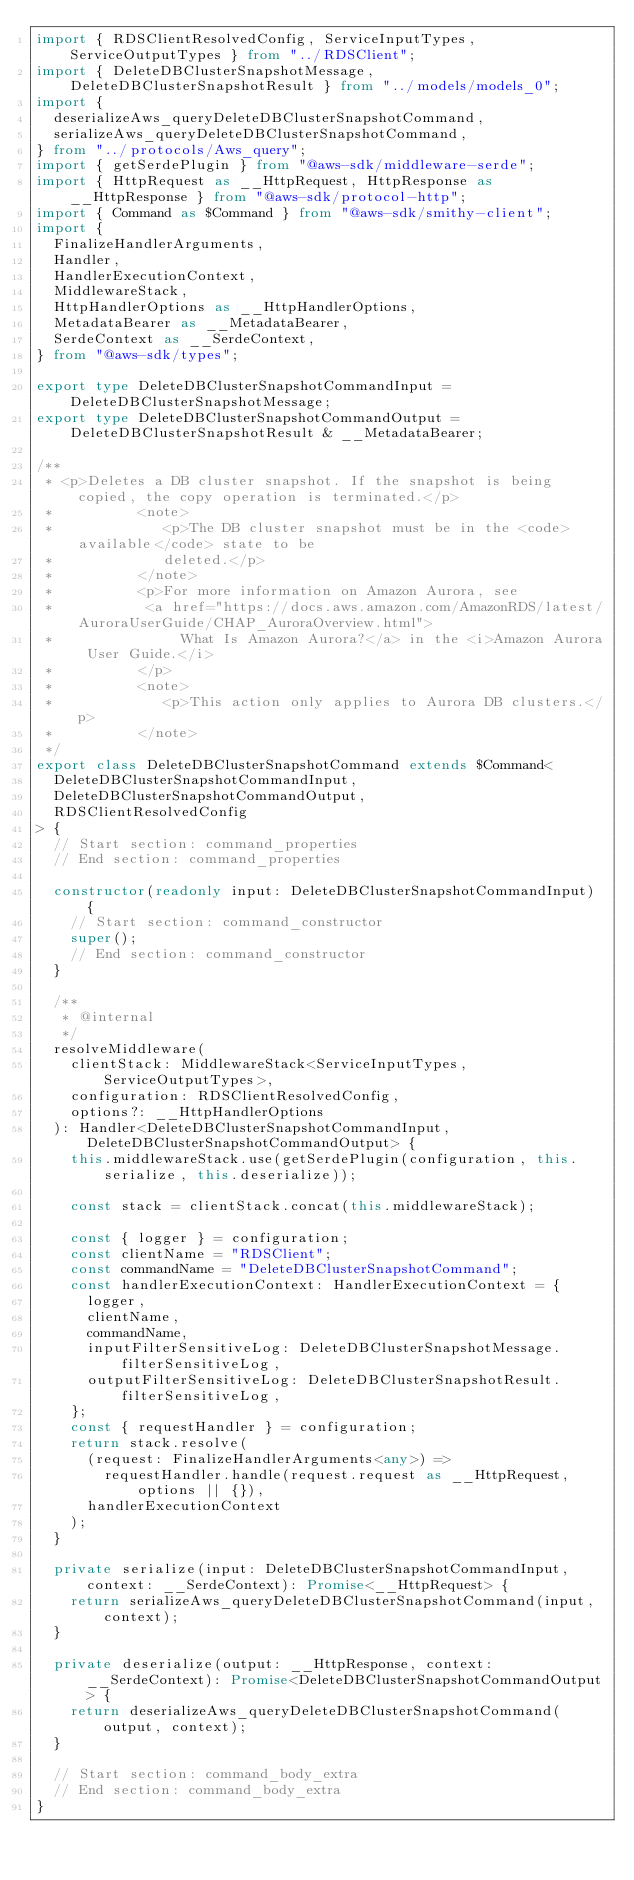Convert code to text. <code><loc_0><loc_0><loc_500><loc_500><_TypeScript_>import { RDSClientResolvedConfig, ServiceInputTypes, ServiceOutputTypes } from "../RDSClient";
import { DeleteDBClusterSnapshotMessage, DeleteDBClusterSnapshotResult } from "../models/models_0";
import {
  deserializeAws_queryDeleteDBClusterSnapshotCommand,
  serializeAws_queryDeleteDBClusterSnapshotCommand,
} from "../protocols/Aws_query";
import { getSerdePlugin } from "@aws-sdk/middleware-serde";
import { HttpRequest as __HttpRequest, HttpResponse as __HttpResponse } from "@aws-sdk/protocol-http";
import { Command as $Command } from "@aws-sdk/smithy-client";
import {
  FinalizeHandlerArguments,
  Handler,
  HandlerExecutionContext,
  MiddlewareStack,
  HttpHandlerOptions as __HttpHandlerOptions,
  MetadataBearer as __MetadataBearer,
  SerdeContext as __SerdeContext,
} from "@aws-sdk/types";

export type DeleteDBClusterSnapshotCommandInput = DeleteDBClusterSnapshotMessage;
export type DeleteDBClusterSnapshotCommandOutput = DeleteDBClusterSnapshotResult & __MetadataBearer;

/**
 * <p>Deletes a DB cluster snapshot. If the snapshot is being copied, the copy operation is terminated.</p>
 *          <note>
 *             <p>The DB cluster snapshot must be in the <code>available</code> state to be
 *             deleted.</p>
 *          </note>
 *          <p>For more information on Amazon Aurora, see
 *           <a href="https://docs.aws.amazon.com/AmazonRDS/latest/AuroraUserGuide/CHAP_AuroraOverview.html">
 *               What Is Amazon Aurora?</a> in the <i>Amazon Aurora User Guide.</i>
 *          </p>
 *          <note>
 *             <p>This action only applies to Aurora DB clusters.</p>
 *          </note>
 */
export class DeleteDBClusterSnapshotCommand extends $Command<
  DeleteDBClusterSnapshotCommandInput,
  DeleteDBClusterSnapshotCommandOutput,
  RDSClientResolvedConfig
> {
  // Start section: command_properties
  // End section: command_properties

  constructor(readonly input: DeleteDBClusterSnapshotCommandInput) {
    // Start section: command_constructor
    super();
    // End section: command_constructor
  }

  /**
   * @internal
   */
  resolveMiddleware(
    clientStack: MiddlewareStack<ServiceInputTypes, ServiceOutputTypes>,
    configuration: RDSClientResolvedConfig,
    options?: __HttpHandlerOptions
  ): Handler<DeleteDBClusterSnapshotCommandInput, DeleteDBClusterSnapshotCommandOutput> {
    this.middlewareStack.use(getSerdePlugin(configuration, this.serialize, this.deserialize));

    const stack = clientStack.concat(this.middlewareStack);

    const { logger } = configuration;
    const clientName = "RDSClient";
    const commandName = "DeleteDBClusterSnapshotCommand";
    const handlerExecutionContext: HandlerExecutionContext = {
      logger,
      clientName,
      commandName,
      inputFilterSensitiveLog: DeleteDBClusterSnapshotMessage.filterSensitiveLog,
      outputFilterSensitiveLog: DeleteDBClusterSnapshotResult.filterSensitiveLog,
    };
    const { requestHandler } = configuration;
    return stack.resolve(
      (request: FinalizeHandlerArguments<any>) =>
        requestHandler.handle(request.request as __HttpRequest, options || {}),
      handlerExecutionContext
    );
  }

  private serialize(input: DeleteDBClusterSnapshotCommandInput, context: __SerdeContext): Promise<__HttpRequest> {
    return serializeAws_queryDeleteDBClusterSnapshotCommand(input, context);
  }

  private deserialize(output: __HttpResponse, context: __SerdeContext): Promise<DeleteDBClusterSnapshotCommandOutput> {
    return deserializeAws_queryDeleteDBClusterSnapshotCommand(output, context);
  }

  // Start section: command_body_extra
  // End section: command_body_extra
}
</code> 